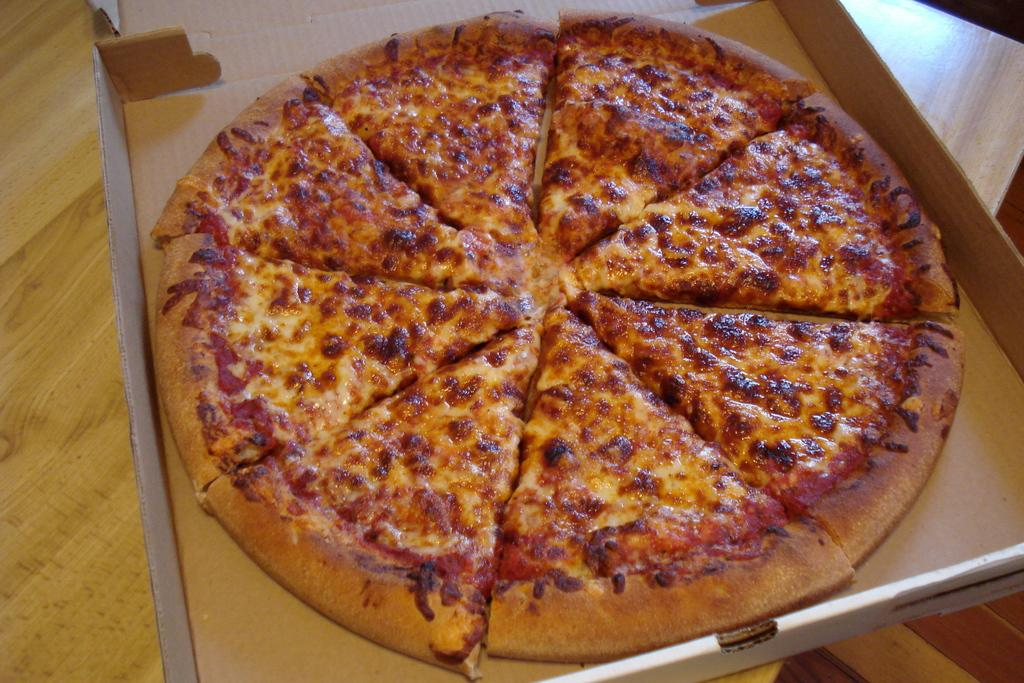What type of food is shown in the image? There is a pizza in the image. How is the pizza being stored or transported? The pizza is in a pizza box. What piece of furniture is present in the image? There is a table in the image. What type of trousers is the pizza wearing in the image? The pizza is not a living being and therefore cannot wear trousers. 